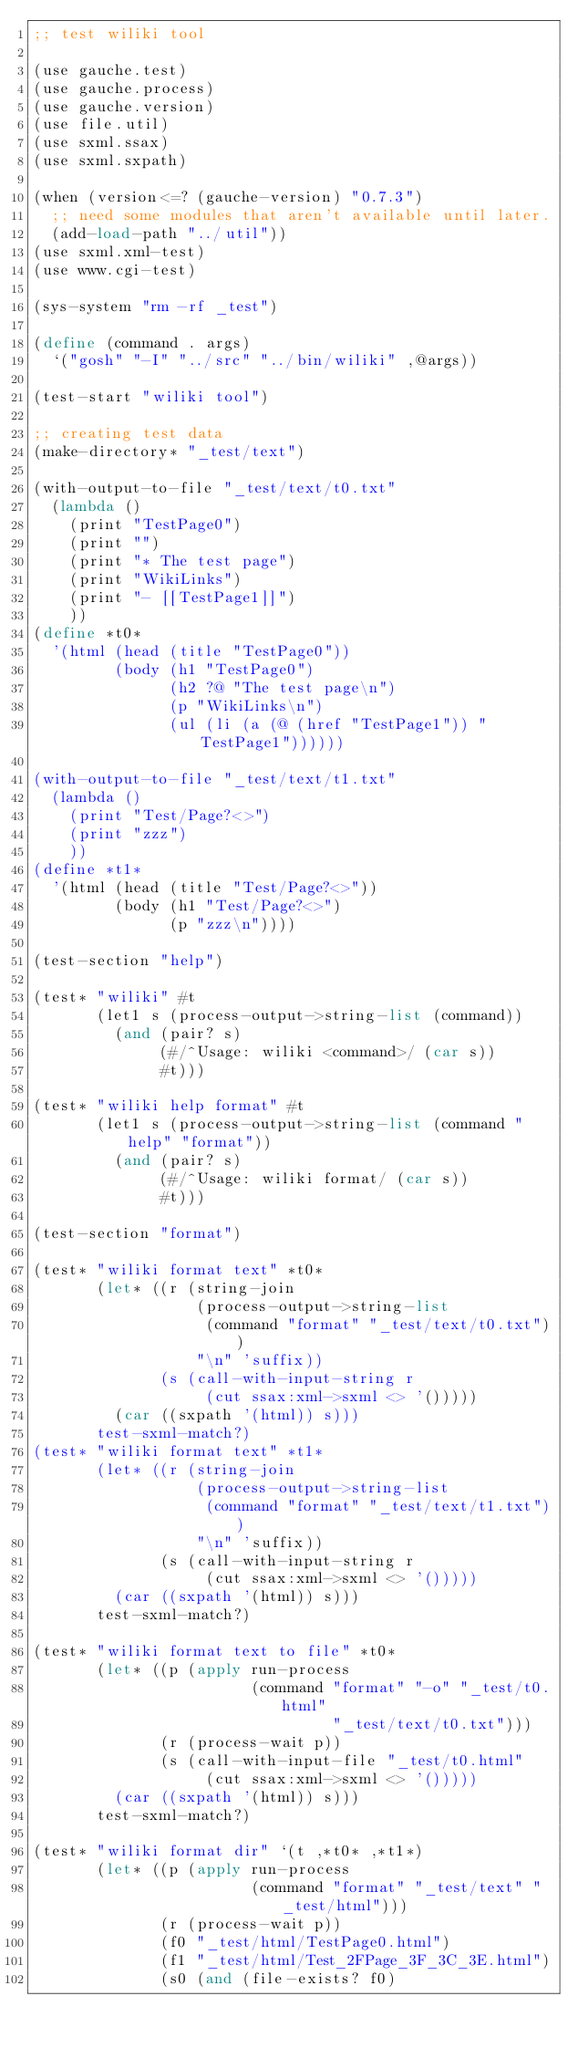<code> <loc_0><loc_0><loc_500><loc_500><_Scheme_>;; test wiliki tool

(use gauche.test)
(use gauche.process)
(use gauche.version)
(use file.util)
(use sxml.ssax)
(use sxml.sxpath)

(when (version<=? (gauche-version) "0.7.3")
  ;; need some modules that aren't available until later.
  (add-load-path "../util"))
(use sxml.xml-test)
(use www.cgi-test)

(sys-system "rm -rf _test")

(define (command . args)
  `("gosh" "-I" "../src" "../bin/wiliki" ,@args))

(test-start "wiliki tool")

;; creating test data
(make-directory* "_test/text")

(with-output-to-file "_test/text/t0.txt"
  (lambda ()
    (print "TestPage0")
    (print "")
    (print "* The test page")
    (print "WikiLinks")
    (print "- [[TestPage1]]")
    ))
(define *t0*
  '(html (head (title "TestPage0"))
         (body (h1 "TestPage0")
               (h2 ?@ "The test page\n")
               (p "WikiLinks\n")
               (ul (li (a (@ (href "TestPage1")) "TestPage1"))))))

(with-output-to-file "_test/text/t1.txt"
  (lambda ()
    (print "Test/Page?<>")
    (print "zzz")
    ))
(define *t1*
  '(html (head (title "Test/Page?<>"))
         (body (h1 "Test/Page?<>")
               (p "zzz\n"))))

(test-section "help")

(test* "wiliki" #t
       (let1 s (process-output->string-list (command))
         (and (pair? s)
              (#/^Usage: wiliki <command>/ (car s))
              #t)))

(test* "wiliki help format" #t
       (let1 s (process-output->string-list (command "help" "format"))
         (and (pair? s)
              (#/^Usage: wiliki format/ (car s))
              #t)))

(test-section "format")

(test* "wiliki format text" *t0*
       (let* ((r (string-join
                  (process-output->string-list
                   (command "format" "_test/text/t0.txt"))
                  "\n" 'suffix))
              (s (call-with-input-string r
                   (cut ssax:xml->sxml <> '()))))
         (car ((sxpath '(html)) s)))
       test-sxml-match?)
(test* "wiliki format text" *t1*
       (let* ((r (string-join
                  (process-output->string-list
                   (command "format" "_test/text/t1.txt"))
                  "\n" 'suffix))
              (s (call-with-input-string r
                   (cut ssax:xml->sxml <> '()))))
         (car ((sxpath '(html)) s)))
       test-sxml-match?)

(test* "wiliki format text to file" *t0*
       (let* ((p (apply run-process
                        (command "format" "-o" "_test/t0.html"
                                 "_test/text/t0.txt")))
              (r (process-wait p))
              (s (call-with-input-file "_test/t0.html"
                   (cut ssax:xml->sxml <> '()))))
         (car ((sxpath '(html)) s)))
       test-sxml-match?)

(test* "wiliki format dir" `(t ,*t0* ,*t1*)
       (let* ((p (apply run-process
                        (command "format" "_test/text" "_test/html")))
              (r (process-wait p))
              (f0 "_test/html/TestPage0.html")
              (f1 "_test/html/Test_2FPage_3F_3C_3E.html")
              (s0 (and (file-exists? f0)</code> 